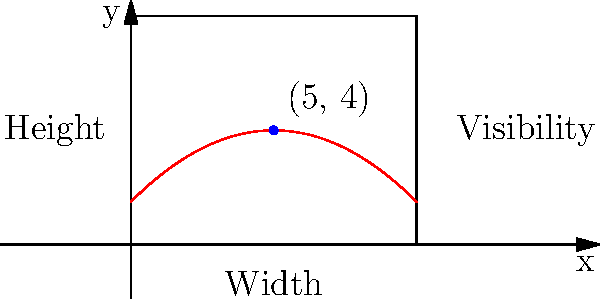A movie poster is represented by a 10 units wide and 8 units tall rectangle. The visibility of a point on the poster can be modeled by the function $f(x) = -0.1(x-5)^2 + 4$, where $x$ is the horizontal distance from the left edge of the poster. What are the coordinates of the point on the poster that maximizes visibility? To find the point of maximum visibility, we need to follow these steps:

1) The function $f(x) = -0.1(x-5)^2 + 4$ is a quadratic function with a negative coefficient for the $x^2$ term, which means it's a downward-facing parabola.

2) For a quadratic function in the form $f(x) = a(x-h)^2 + k$, the vertex is at the point $(h,k)$.

3) In our case, $f(x) = -0.1(x-5)^2 + 4$, so $h=5$ and $k=4$.

4) The vertex of a parabola represents its maximum point for a downward-facing parabola.

5) Therefore, the point of maximum visibility is at $x=5$ (horizontally centered on the poster) and $y=4$ (halfway up the poster's height).

6) The coordinates of this point are $(5,4)$.

This point makes sense intuitively as well, as it's at the center of the poster, where visibility would likely be highest.
Answer: $(5,4)$ 